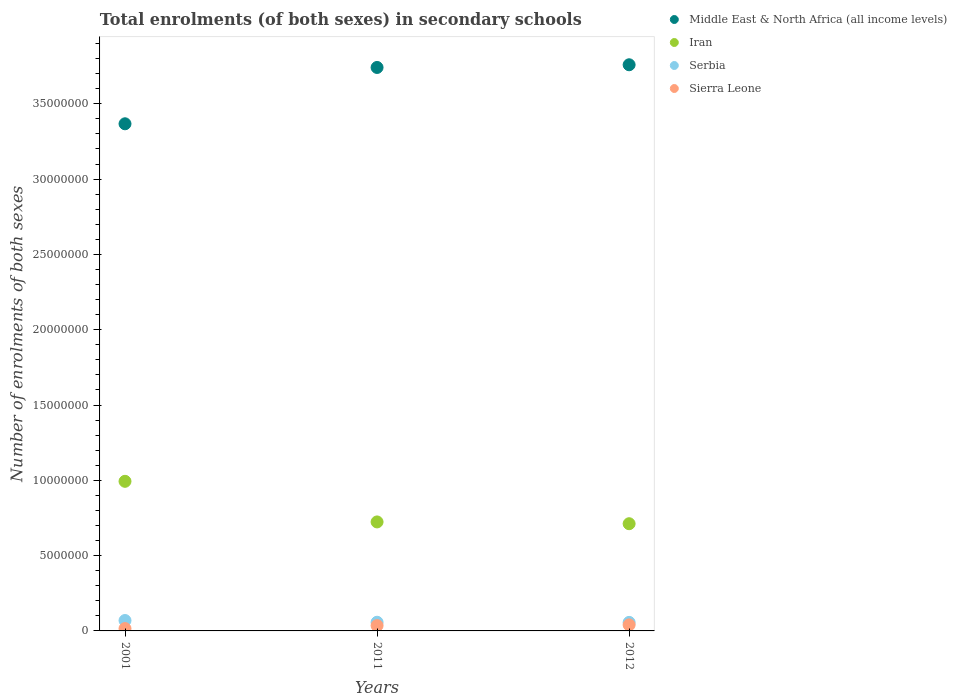How many different coloured dotlines are there?
Make the answer very short. 4. What is the number of enrolments in secondary schools in Iran in 2012?
Offer a very short reply. 7.12e+06. Across all years, what is the maximum number of enrolments in secondary schools in Serbia?
Your response must be concise. 6.91e+05. Across all years, what is the minimum number of enrolments in secondary schools in Iran?
Offer a terse response. 7.12e+06. In which year was the number of enrolments in secondary schools in Sierra Leone minimum?
Your response must be concise. 2001. What is the total number of enrolments in secondary schools in Iran in the graph?
Your response must be concise. 2.43e+07. What is the difference between the number of enrolments in secondary schools in Middle East & North Africa (all income levels) in 2011 and that in 2012?
Give a very brief answer. -1.79e+05. What is the difference between the number of enrolments in secondary schools in Serbia in 2011 and the number of enrolments in secondary schools in Middle East & North Africa (all income levels) in 2012?
Your response must be concise. -3.70e+07. What is the average number of enrolments in secondary schools in Middle East & North Africa (all income levels) per year?
Keep it short and to the point. 3.62e+07. In the year 2011, what is the difference between the number of enrolments in secondary schools in Middle East & North Africa (all income levels) and number of enrolments in secondary schools in Iran?
Your response must be concise. 3.02e+07. What is the ratio of the number of enrolments in secondary schools in Middle East & North Africa (all income levels) in 2001 to that in 2011?
Your answer should be compact. 0.9. What is the difference between the highest and the second highest number of enrolments in secondary schools in Sierra Leone?
Offer a very short reply. 4.81e+04. What is the difference between the highest and the lowest number of enrolments in secondary schools in Sierra Leone?
Offer a terse response. 2.45e+05. In how many years, is the number of enrolments in secondary schools in Sierra Leone greater than the average number of enrolments in secondary schools in Sierra Leone taken over all years?
Offer a very short reply. 2. Is the sum of the number of enrolments in secondary schools in Sierra Leone in 2001 and 2012 greater than the maximum number of enrolments in secondary schools in Middle East & North Africa (all income levels) across all years?
Offer a terse response. No. Is it the case that in every year, the sum of the number of enrolments in secondary schools in Sierra Leone and number of enrolments in secondary schools in Iran  is greater than the number of enrolments in secondary schools in Serbia?
Offer a very short reply. Yes. Is the number of enrolments in secondary schools in Middle East & North Africa (all income levels) strictly greater than the number of enrolments in secondary schools in Iran over the years?
Keep it short and to the point. Yes. Is the number of enrolments in secondary schools in Middle East & North Africa (all income levels) strictly less than the number of enrolments in secondary schools in Serbia over the years?
Make the answer very short. No. How many dotlines are there?
Make the answer very short. 4. How many years are there in the graph?
Give a very brief answer. 3. Does the graph contain any zero values?
Provide a short and direct response. No. What is the title of the graph?
Make the answer very short. Total enrolments (of both sexes) in secondary schools. Does "Antigua and Barbuda" appear as one of the legend labels in the graph?
Offer a very short reply. No. What is the label or title of the Y-axis?
Your response must be concise. Number of enrolments of both sexes. What is the Number of enrolments of both sexes of Middle East & North Africa (all income levels) in 2001?
Your response must be concise. 3.37e+07. What is the Number of enrolments of both sexes of Iran in 2001?
Provide a succinct answer. 9.93e+06. What is the Number of enrolments of both sexes in Serbia in 2001?
Keep it short and to the point. 6.91e+05. What is the Number of enrolments of both sexes in Sierra Leone in 2001?
Give a very brief answer. 1.56e+05. What is the Number of enrolments of both sexes in Middle East & North Africa (all income levels) in 2011?
Offer a terse response. 3.74e+07. What is the Number of enrolments of both sexes in Iran in 2011?
Provide a short and direct response. 7.24e+06. What is the Number of enrolments of both sexes in Serbia in 2011?
Make the answer very short. 5.76e+05. What is the Number of enrolments of both sexes of Sierra Leone in 2011?
Provide a short and direct response. 3.53e+05. What is the Number of enrolments of both sexes of Middle East & North Africa (all income levels) in 2012?
Your answer should be very brief. 3.76e+07. What is the Number of enrolments of both sexes in Iran in 2012?
Provide a succinct answer. 7.12e+06. What is the Number of enrolments of both sexes in Serbia in 2012?
Give a very brief answer. 5.66e+05. What is the Number of enrolments of both sexes of Sierra Leone in 2012?
Offer a very short reply. 4.01e+05. Across all years, what is the maximum Number of enrolments of both sexes of Middle East & North Africa (all income levels)?
Provide a succinct answer. 3.76e+07. Across all years, what is the maximum Number of enrolments of both sexes of Iran?
Keep it short and to the point. 9.93e+06. Across all years, what is the maximum Number of enrolments of both sexes in Serbia?
Provide a short and direct response. 6.91e+05. Across all years, what is the maximum Number of enrolments of both sexes of Sierra Leone?
Your answer should be very brief. 4.01e+05. Across all years, what is the minimum Number of enrolments of both sexes of Middle East & North Africa (all income levels)?
Provide a short and direct response. 3.37e+07. Across all years, what is the minimum Number of enrolments of both sexes of Iran?
Offer a terse response. 7.12e+06. Across all years, what is the minimum Number of enrolments of both sexes of Serbia?
Offer a terse response. 5.66e+05. Across all years, what is the minimum Number of enrolments of both sexes in Sierra Leone?
Provide a short and direct response. 1.56e+05. What is the total Number of enrolments of both sexes in Middle East & North Africa (all income levels) in the graph?
Your answer should be very brief. 1.09e+08. What is the total Number of enrolments of both sexes in Iran in the graph?
Give a very brief answer. 2.43e+07. What is the total Number of enrolments of both sexes in Serbia in the graph?
Make the answer very short. 1.83e+06. What is the total Number of enrolments of both sexes in Sierra Leone in the graph?
Make the answer very short. 9.09e+05. What is the difference between the Number of enrolments of both sexes in Middle East & North Africa (all income levels) in 2001 and that in 2011?
Offer a terse response. -3.74e+06. What is the difference between the Number of enrolments of both sexes of Iran in 2001 and that in 2011?
Provide a short and direct response. 2.70e+06. What is the difference between the Number of enrolments of both sexes of Serbia in 2001 and that in 2011?
Offer a very short reply. 1.15e+05. What is the difference between the Number of enrolments of both sexes in Sierra Leone in 2001 and that in 2011?
Ensure brevity in your answer.  -1.97e+05. What is the difference between the Number of enrolments of both sexes in Middle East & North Africa (all income levels) in 2001 and that in 2012?
Provide a succinct answer. -3.92e+06. What is the difference between the Number of enrolments of both sexes in Iran in 2001 and that in 2012?
Offer a terse response. 2.82e+06. What is the difference between the Number of enrolments of both sexes in Serbia in 2001 and that in 2012?
Your answer should be compact. 1.25e+05. What is the difference between the Number of enrolments of both sexes in Sierra Leone in 2001 and that in 2012?
Your answer should be very brief. -2.45e+05. What is the difference between the Number of enrolments of both sexes of Middle East & North Africa (all income levels) in 2011 and that in 2012?
Keep it short and to the point. -1.79e+05. What is the difference between the Number of enrolments of both sexes of Iran in 2011 and that in 2012?
Offer a very short reply. 1.19e+05. What is the difference between the Number of enrolments of both sexes in Serbia in 2011 and that in 2012?
Offer a terse response. 1.01e+04. What is the difference between the Number of enrolments of both sexes of Sierra Leone in 2011 and that in 2012?
Provide a succinct answer. -4.81e+04. What is the difference between the Number of enrolments of both sexes in Middle East & North Africa (all income levels) in 2001 and the Number of enrolments of both sexes in Iran in 2011?
Your answer should be very brief. 2.64e+07. What is the difference between the Number of enrolments of both sexes in Middle East & North Africa (all income levels) in 2001 and the Number of enrolments of both sexes in Serbia in 2011?
Your answer should be very brief. 3.31e+07. What is the difference between the Number of enrolments of both sexes in Middle East & North Africa (all income levels) in 2001 and the Number of enrolments of both sexes in Sierra Leone in 2011?
Your answer should be very brief. 3.33e+07. What is the difference between the Number of enrolments of both sexes in Iran in 2001 and the Number of enrolments of both sexes in Serbia in 2011?
Offer a terse response. 9.36e+06. What is the difference between the Number of enrolments of both sexes in Iran in 2001 and the Number of enrolments of both sexes in Sierra Leone in 2011?
Provide a succinct answer. 9.58e+06. What is the difference between the Number of enrolments of both sexes of Serbia in 2001 and the Number of enrolments of both sexes of Sierra Leone in 2011?
Provide a short and direct response. 3.38e+05. What is the difference between the Number of enrolments of both sexes of Middle East & North Africa (all income levels) in 2001 and the Number of enrolments of both sexes of Iran in 2012?
Your answer should be very brief. 2.66e+07. What is the difference between the Number of enrolments of both sexes of Middle East & North Africa (all income levels) in 2001 and the Number of enrolments of both sexes of Serbia in 2012?
Offer a very short reply. 3.31e+07. What is the difference between the Number of enrolments of both sexes in Middle East & North Africa (all income levels) in 2001 and the Number of enrolments of both sexes in Sierra Leone in 2012?
Provide a succinct answer. 3.33e+07. What is the difference between the Number of enrolments of both sexes in Iran in 2001 and the Number of enrolments of both sexes in Serbia in 2012?
Your response must be concise. 9.37e+06. What is the difference between the Number of enrolments of both sexes of Iran in 2001 and the Number of enrolments of both sexes of Sierra Leone in 2012?
Keep it short and to the point. 9.53e+06. What is the difference between the Number of enrolments of both sexes in Serbia in 2001 and the Number of enrolments of both sexes in Sierra Leone in 2012?
Your answer should be compact. 2.90e+05. What is the difference between the Number of enrolments of both sexes of Middle East & North Africa (all income levels) in 2011 and the Number of enrolments of both sexes of Iran in 2012?
Your answer should be very brief. 3.03e+07. What is the difference between the Number of enrolments of both sexes of Middle East & North Africa (all income levels) in 2011 and the Number of enrolments of both sexes of Serbia in 2012?
Provide a short and direct response. 3.68e+07. What is the difference between the Number of enrolments of both sexes of Middle East & North Africa (all income levels) in 2011 and the Number of enrolments of both sexes of Sierra Leone in 2012?
Your answer should be compact. 3.70e+07. What is the difference between the Number of enrolments of both sexes of Iran in 2011 and the Number of enrolments of both sexes of Serbia in 2012?
Provide a short and direct response. 6.67e+06. What is the difference between the Number of enrolments of both sexes in Iran in 2011 and the Number of enrolments of both sexes in Sierra Leone in 2012?
Provide a succinct answer. 6.84e+06. What is the difference between the Number of enrolments of both sexes in Serbia in 2011 and the Number of enrolments of both sexes in Sierra Leone in 2012?
Your response must be concise. 1.75e+05. What is the average Number of enrolments of both sexes of Middle East & North Africa (all income levels) per year?
Make the answer very short. 3.62e+07. What is the average Number of enrolments of both sexes of Iran per year?
Your response must be concise. 8.10e+06. What is the average Number of enrolments of both sexes of Serbia per year?
Ensure brevity in your answer.  6.11e+05. What is the average Number of enrolments of both sexes in Sierra Leone per year?
Your response must be concise. 3.03e+05. In the year 2001, what is the difference between the Number of enrolments of both sexes of Middle East & North Africa (all income levels) and Number of enrolments of both sexes of Iran?
Ensure brevity in your answer.  2.37e+07. In the year 2001, what is the difference between the Number of enrolments of both sexes of Middle East & North Africa (all income levels) and Number of enrolments of both sexes of Serbia?
Provide a succinct answer. 3.30e+07. In the year 2001, what is the difference between the Number of enrolments of both sexes in Middle East & North Africa (all income levels) and Number of enrolments of both sexes in Sierra Leone?
Offer a very short reply. 3.35e+07. In the year 2001, what is the difference between the Number of enrolments of both sexes of Iran and Number of enrolments of both sexes of Serbia?
Provide a short and direct response. 9.24e+06. In the year 2001, what is the difference between the Number of enrolments of both sexes in Iran and Number of enrolments of both sexes in Sierra Leone?
Make the answer very short. 9.78e+06. In the year 2001, what is the difference between the Number of enrolments of both sexes of Serbia and Number of enrolments of both sexes of Sierra Leone?
Offer a very short reply. 5.36e+05. In the year 2011, what is the difference between the Number of enrolments of both sexes in Middle East & North Africa (all income levels) and Number of enrolments of both sexes in Iran?
Your answer should be compact. 3.02e+07. In the year 2011, what is the difference between the Number of enrolments of both sexes of Middle East & North Africa (all income levels) and Number of enrolments of both sexes of Serbia?
Provide a short and direct response. 3.68e+07. In the year 2011, what is the difference between the Number of enrolments of both sexes of Middle East & North Africa (all income levels) and Number of enrolments of both sexes of Sierra Leone?
Your answer should be very brief. 3.71e+07. In the year 2011, what is the difference between the Number of enrolments of both sexes of Iran and Number of enrolments of both sexes of Serbia?
Your answer should be compact. 6.66e+06. In the year 2011, what is the difference between the Number of enrolments of both sexes of Iran and Number of enrolments of both sexes of Sierra Leone?
Your answer should be very brief. 6.88e+06. In the year 2011, what is the difference between the Number of enrolments of both sexes of Serbia and Number of enrolments of both sexes of Sierra Leone?
Give a very brief answer. 2.23e+05. In the year 2012, what is the difference between the Number of enrolments of both sexes in Middle East & North Africa (all income levels) and Number of enrolments of both sexes in Iran?
Keep it short and to the point. 3.05e+07. In the year 2012, what is the difference between the Number of enrolments of both sexes of Middle East & North Africa (all income levels) and Number of enrolments of both sexes of Serbia?
Provide a short and direct response. 3.70e+07. In the year 2012, what is the difference between the Number of enrolments of both sexes in Middle East & North Africa (all income levels) and Number of enrolments of both sexes in Sierra Leone?
Keep it short and to the point. 3.72e+07. In the year 2012, what is the difference between the Number of enrolments of both sexes of Iran and Number of enrolments of both sexes of Serbia?
Offer a very short reply. 6.55e+06. In the year 2012, what is the difference between the Number of enrolments of both sexes of Iran and Number of enrolments of both sexes of Sierra Leone?
Give a very brief answer. 6.72e+06. In the year 2012, what is the difference between the Number of enrolments of both sexes in Serbia and Number of enrolments of both sexes in Sierra Leone?
Make the answer very short. 1.65e+05. What is the ratio of the Number of enrolments of both sexes in Iran in 2001 to that in 2011?
Make the answer very short. 1.37. What is the ratio of the Number of enrolments of both sexes of Serbia in 2001 to that in 2011?
Provide a short and direct response. 1.2. What is the ratio of the Number of enrolments of both sexes of Sierra Leone in 2001 to that in 2011?
Your answer should be very brief. 0.44. What is the ratio of the Number of enrolments of both sexes of Middle East & North Africa (all income levels) in 2001 to that in 2012?
Offer a terse response. 0.9. What is the ratio of the Number of enrolments of both sexes in Iran in 2001 to that in 2012?
Make the answer very short. 1.4. What is the ratio of the Number of enrolments of both sexes of Serbia in 2001 to that in 2012?
Ensure brevity in your answer.  1.22. What is the ratio of the Number of enrolments of both sexes of Sierra Leone in 2001 to that in 2012?
Give a very brief answer. 0.39. What is the ratio of the Number of enrolments of both sexes in Iran in 2011 to that in 2012?
Keep it short and to the point. 1.02. What is the ratio of the Number of enrolments of both sexes of Serbia in 2011 to that in 2012?
Offer a terse response. 1.02. What is the ratio of the Number of enrolments of both sexes in Sierra Leone in 2011 to that in 2012?
Give a very brief answer. 0.88. What is the difference between the highest and the second highest Number of enrolments of both sexes in Middle East & North Africa (all income levels)?
Offer a very short reply. 1.79e+05. What is the difference between the highest and the second highest Number of enrolments of both sexes of Iran?
Offer a very short reply. 2.70e+06. What is the difference between the highest and the second highest Number of enrolments of both sexes in Serbia?
Give a very brief answer. 1.15e+05. What is the difference between the highest and the second highest Number of enrolments of both sexes of Sierra Leone?
Your response must be concise. 4.81e+04. What is the difference between the highest and the lowest Number of enrolments of both sexes of Middle East & North Africa (all income levels)?
Give a very brief answer. 3.92e+06. What is the difference between the highest and the lowest Number of enrolments of both sexes in Iran?
Provide a succinct answer. 2.82e+06. What is the difference between the highest and the lowest Number of enrolments of both sexes in Serbia?
Your answer should be compact. 1.25e+05. What is the difference between the highest and the lowest Number of enrolments of both sexes of Sierra Leone?
Keep it short and to the point. 2.45e+05. 